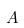<formula> <loc_0><loc_0><loc_500><loc_500>A</formula> 